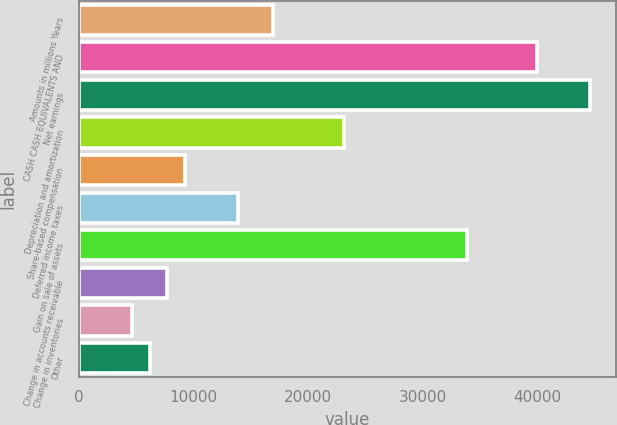Convert chart to OTSL. <chart><loc_0><loc_0><loc_500><loc_500><bar_chart><fcel>Amounts in millions Years<fcel>CASH CASH EQUIVALENTS AND<fcel>Net earnings<fcel>Depreciation and amortization<fcel>Share-based compensation<fcel>Deferred income taxes<fcel>Gain on sale of assets<fcel>Change in accounts receivable<fcel>Change in inventories<fcel>Other<nl><fcel>16950.5<fcel>40043<fcel>44661.5<fcel>23108.5<fcel>9253<fcel>13871.5<fcel>33885<fcel>7713.5<fcel>4634.5<fcel>6174<nl></chart> 